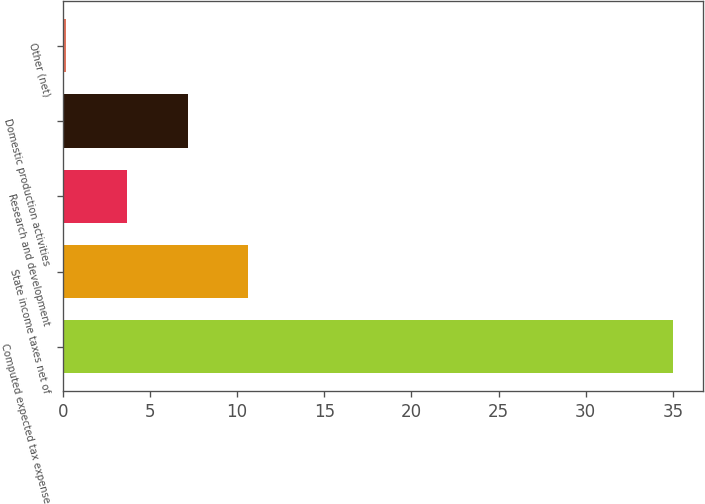<chart> <loc_0><loc_0><loc_500><loc_500><bar_chart><fcel>Computed expected tax expense<fcel>State income taxes net of<fcel>Research and development<fcel>Domestic production activities<fcel>Other (net)<nl><fcel>35<fcel>10.64<fcel>3.68<fcel>7.16<fcel>0.2<nl></chart> 